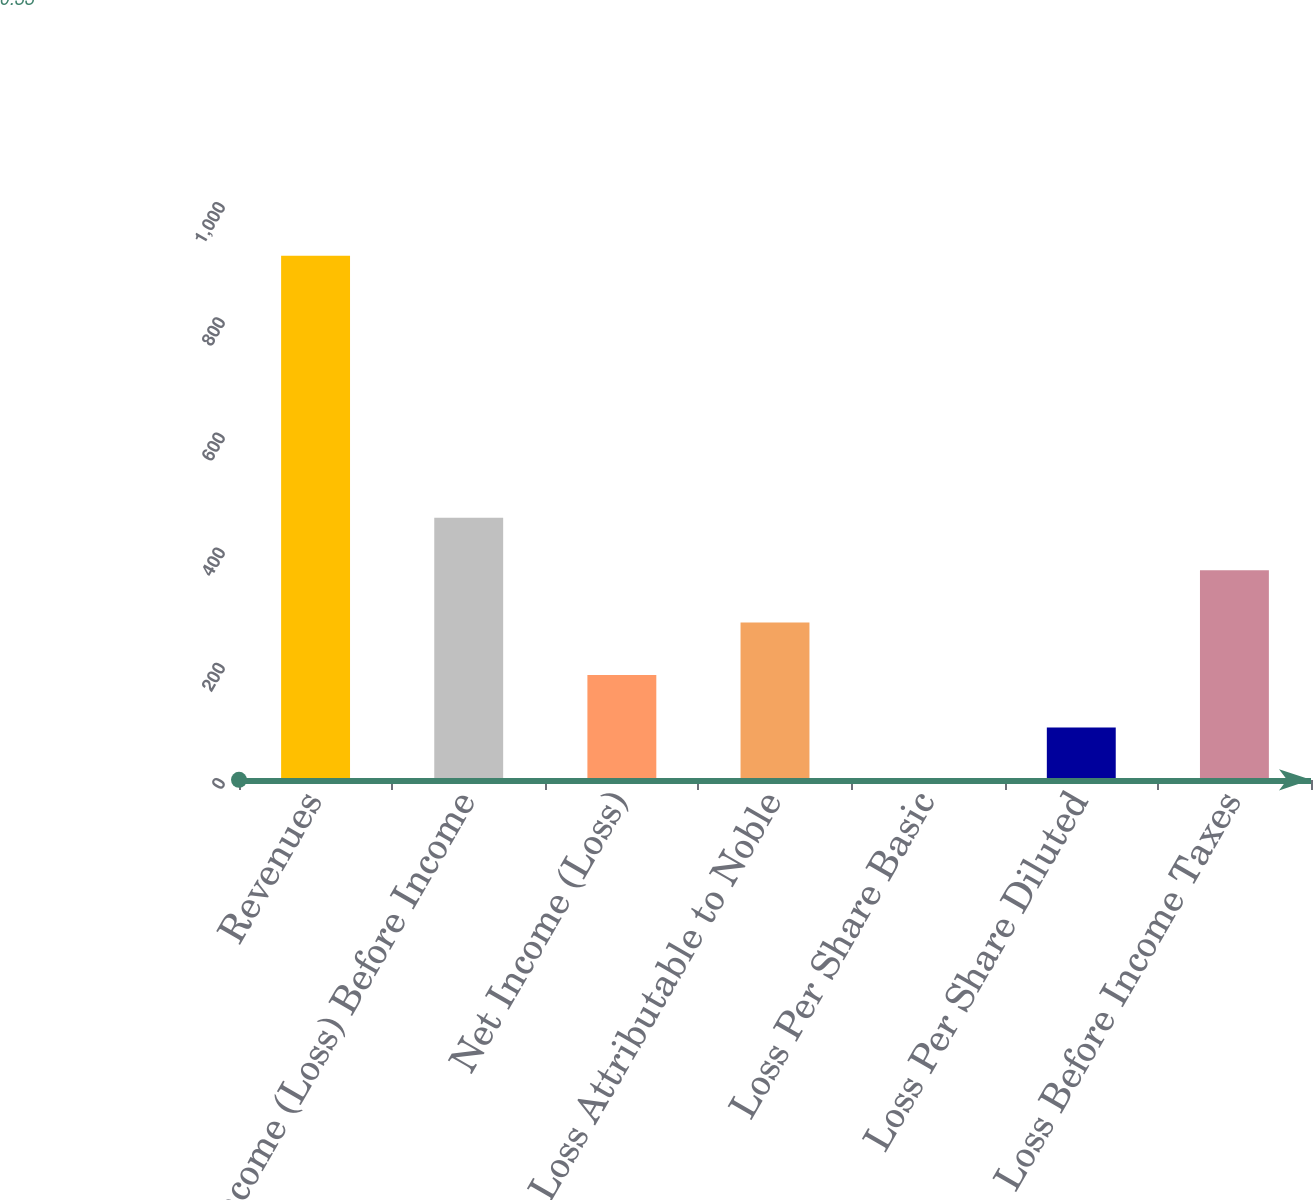<chart> <loc_0><loc_0><loc_500><loc_500><bar_chart><fcel>Revenues<fcel>Income (Loss) Before Income<fcel>Net Income (Loss)<fcel>Net Loss Attributable to Noble<fcel>Loss Per Share Basic<fcel>Loss Per Share Diluted<fcel>Loss Before Income Taxes<nl><fcel>910<fcel>455.18<fcel>182.27<fcel>273.24<fcel>0.33<fcel>91.3<fcel>364.21<nl></chart> 